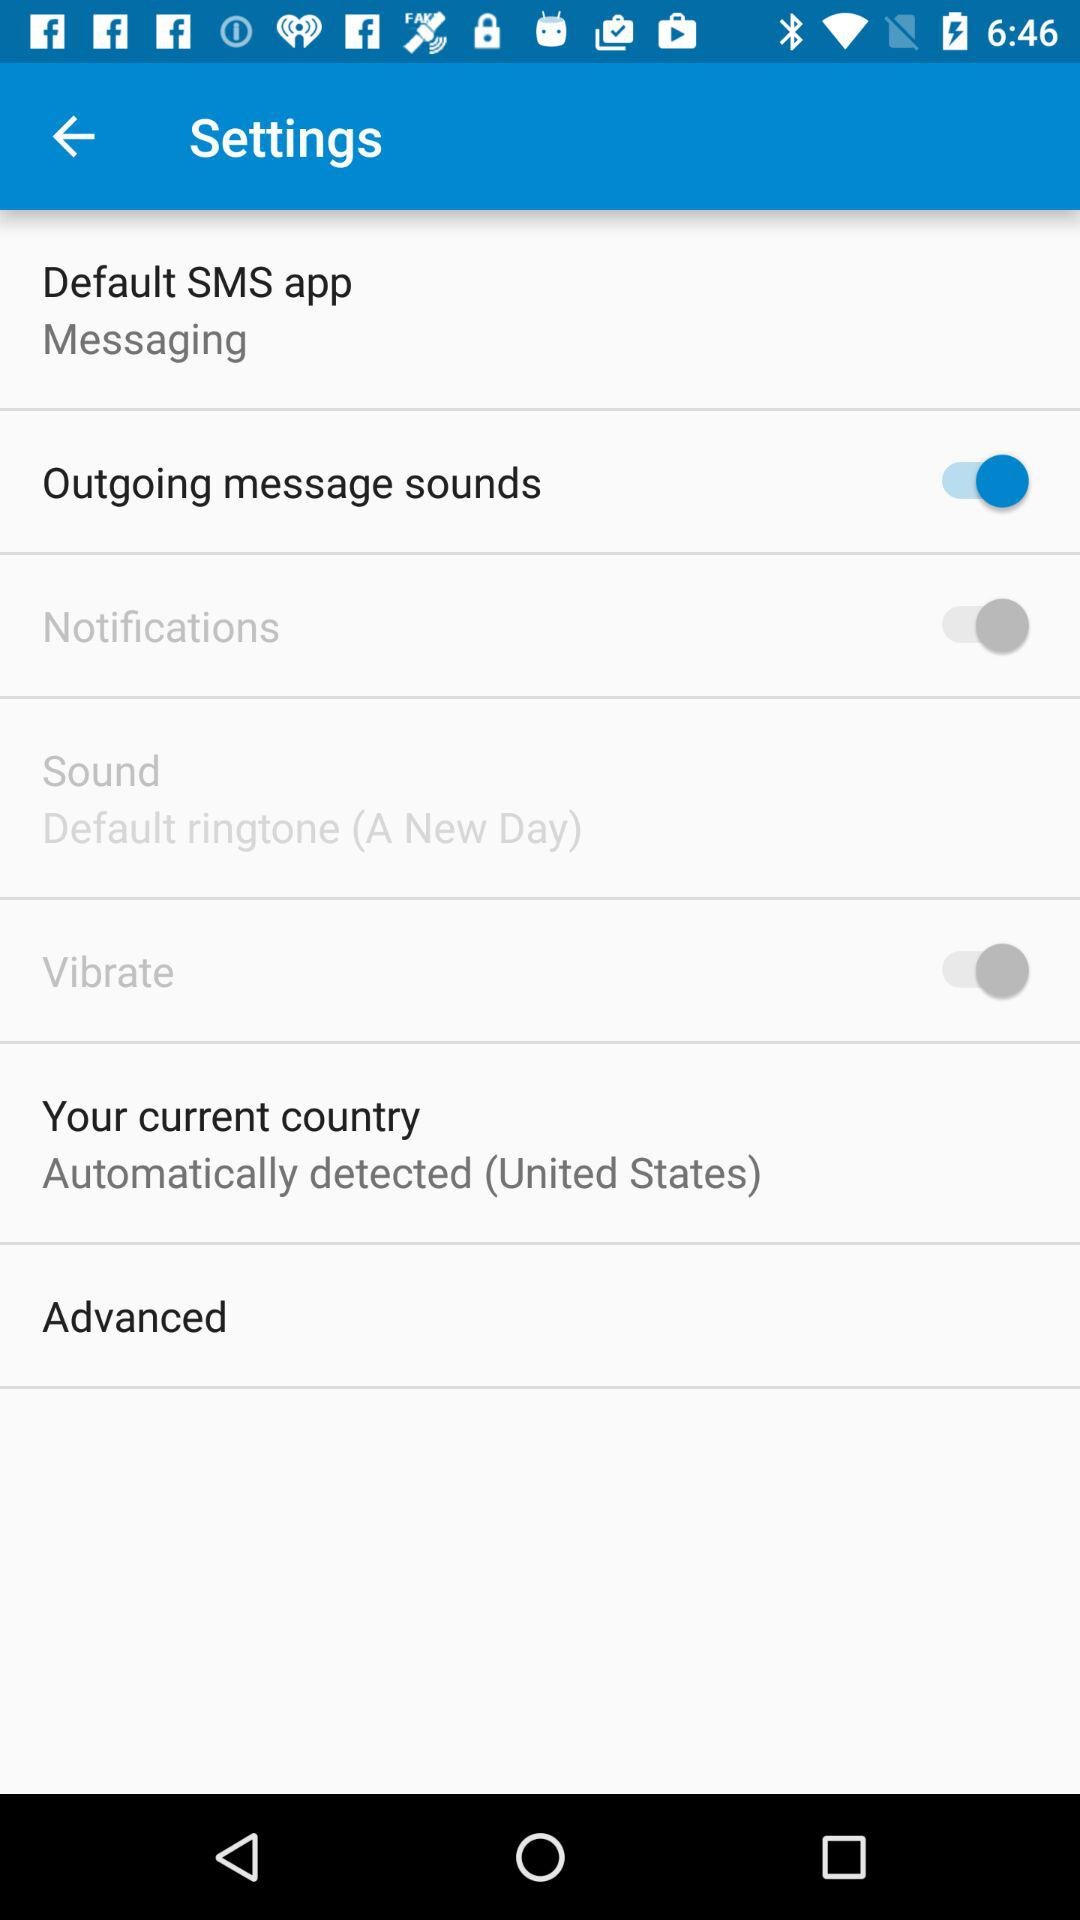What is the setting for "Outgoing message sounds"? The setting for "Outgoing message sounds" is "on". 